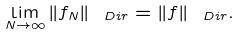<formula> <loc_0><loc_0><loc_500><loc_500>\lim _ { N \to \infty } \| f _ { N } \| _ { \ D i r } = \| f \| _ { \ D i r } .</formula> 